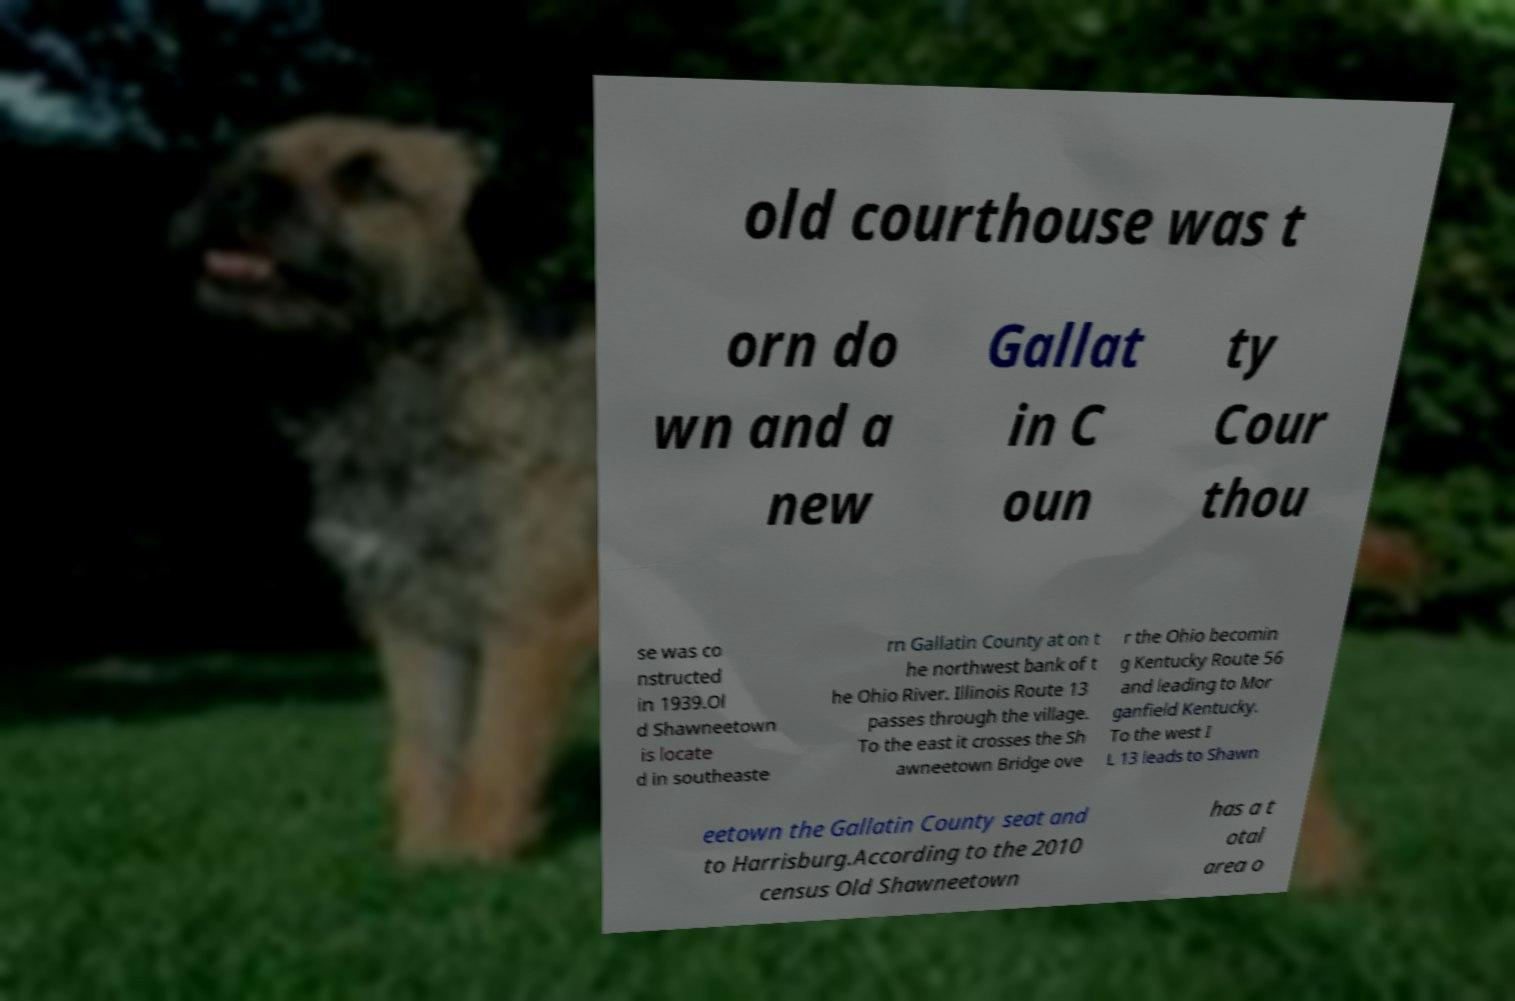Could you extract and type out the text from this image? old courthouse was t orn do wn and a new Gallat in C oun ty Cour thou se was co nstructed in 1939.Ol d Shawneetown is locate d in southeaste rn Gallatin County at on t he northwest bank of t he Ohio River. Illinois Route 13 passes through the village. To the east it crosses the Sh awneetown Bridge ove r the Ohio becomin g Kentucky Route 56 and leading to Mor ganfield Kentucky. To the west I L 13 leads to Shawn eetown the Gallatin County seat and to Harrisburg.According to the 2010 census Old Shawneetown has a t otal area o 